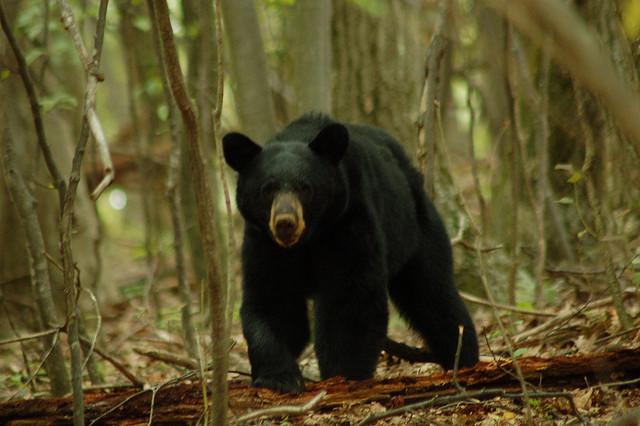Is this bear stalking the camera person?
Quick response, please. Yes. Is the tree laying on the ground rotten?
Be succinct. Yes. What kind of bear is in this picture?
Be succinct. Black. Is this bear at the zoo?
Keep it brief. No. Is this bear in the woods?
Be succinct. Yes. 